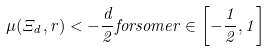Convert formula to latex. <formula><loc_0><loc_0><loc_500><loc_500>\mu ( \Xi _ { d } , r ) < - \frac { d } { 2 } f o r s o m e r \in \left [ - \frac { 1 } { 2 } , 1 \right ]</formula> 